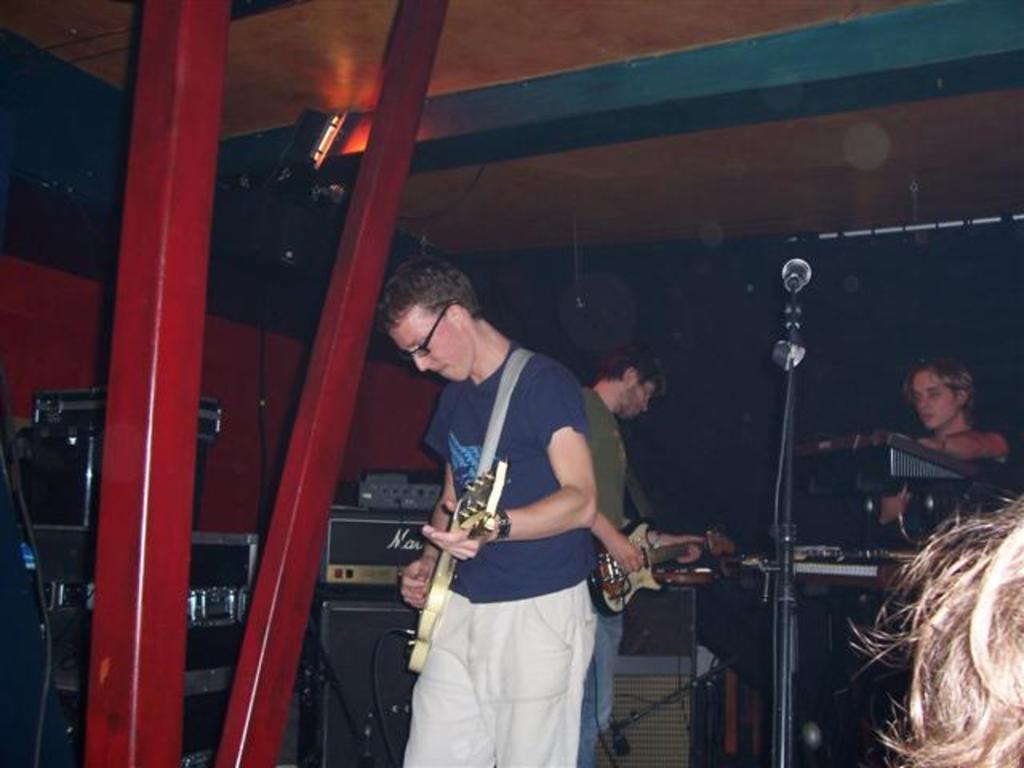Can you describe this image briefly? In this image there are group of persons who are playing musical instruments and at the background of the image there are sound boxes,microphones. 